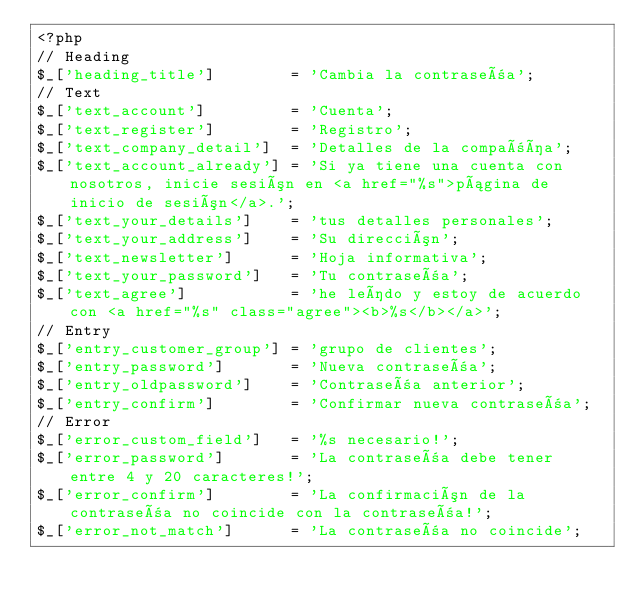<code> <loc_0><loc_0><loc_500><loc_500><_PHP_><?php
// Heading
$_['heading_title']        = 'Cambia la contraseña';
// Text
$_['text_account']         = 'Cuenta';
$_['text_register']        = 'Registro';
$_['text_company_detail']  = 'Detalles de la compañía';
$_['text_account_already'] = 'Si ya tiene una cuenta con nosotros, inicie sesión en <a href="%s">página de inicio de sesión</a>.';
$_['text_your_details']    = 'tus detalles personales';
$_['text_your_address']    = 'Su dirección';
$_['text_newsletter']      = 'Hoja informativa';
$_['text_your_password']   = 'Tu contraseña';
$_['text_agree']           = 'he leído y estoy de acuerdo con <a href="%s" class="agree"><b>%s</b></a>';
// Entry
$_['entry_customer_group'] = 'grupo de clientes';
$_['entry_password']       = 'Nueva contraseña';
$_['entry_oldpassword']    = 'Contraseña anterior';
$_['entry_confirm']        = 'Confirmar nueva contraseña';
// Error
$_['error_custom_field']   = '%s necesario!';
$_['error_password']       = 'La contraseña debe tener entre 4 y 20 caracteres!';
$_['error_confirm']        = 'La confirmación de la contraseña no coincide con la contraseña!';
$_['error_not_match']      = 'La contraseña no coincide';
</code> 